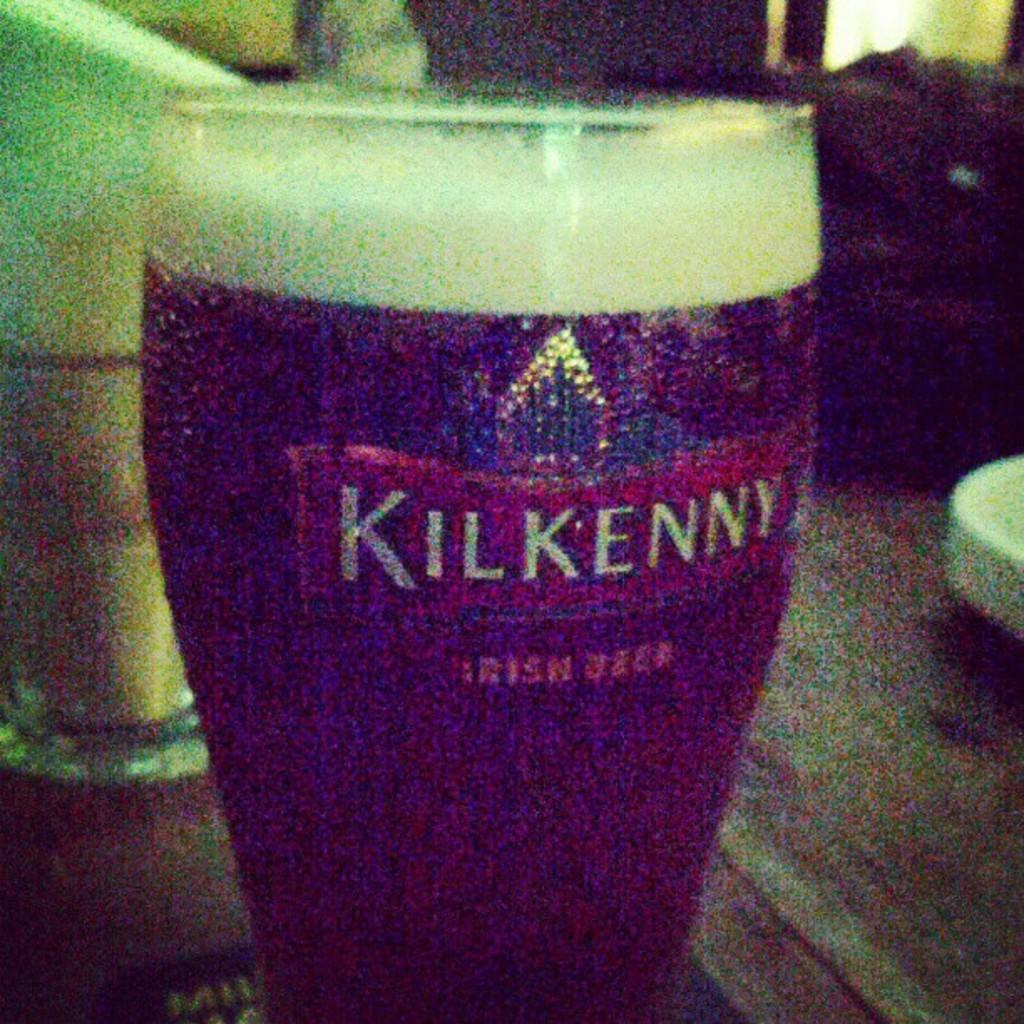<image>
Create a compact narrative representing the image presented. A glass of Kilkenny beer is sitting on a wooden table. 